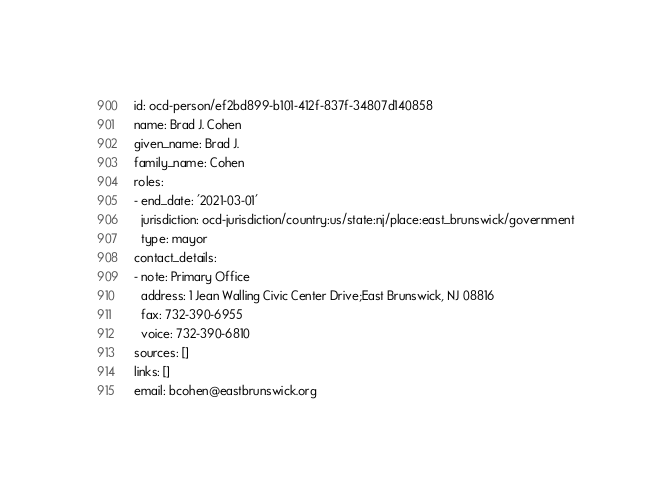<code> <loc_0><loc_0><loc_500><loc_500><_YAML_>id: ocd-person/ef2bd899-b101-412f-837f-34807d140858
name: Brad J. Cohen
given_name: Brad J.
family_name: Cohen
roles:
- end_date: '2021-03-01'
  jurisdiction: ocd-jurisdiction/country:us/state:nj/place:east_brunswick/government
  type: mayor
contact_details:
- note: Primary Office
  address: 1 Jean Walling Civic Center Drive;East Brunswick, NJ 08816
  fax: 732-390-6955
  voice: 732-390-6810
sources: []
links: []
email: bcohen@eastbrunswick.org
</code> 